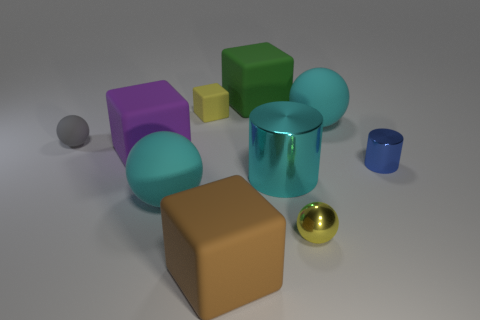Subtract all green rubber blocks. How many blocks are left? 3 Subtract all red cylinders. How many cyan spheres are left? 2 Subtract all cubes. How many objects are left? 6 Subtract all gray spheres. How many spheres are left? 3 Subtract 3 balls. How many balls are left? 1 Subtract 1 green cubes. How many objects are left? 9 Subtract all cyan cubes. Subtract all yellow cylinders. How many cubes are left? 4 Subtract all matte blocks. Subtract all large cyan cylinders. How many objects are left? 5 Add 4 rubber spheres. How many rubber spheres are left? 7 Add 3 tiny metal cylinders. How many tiny metal cylinders exist? 4 